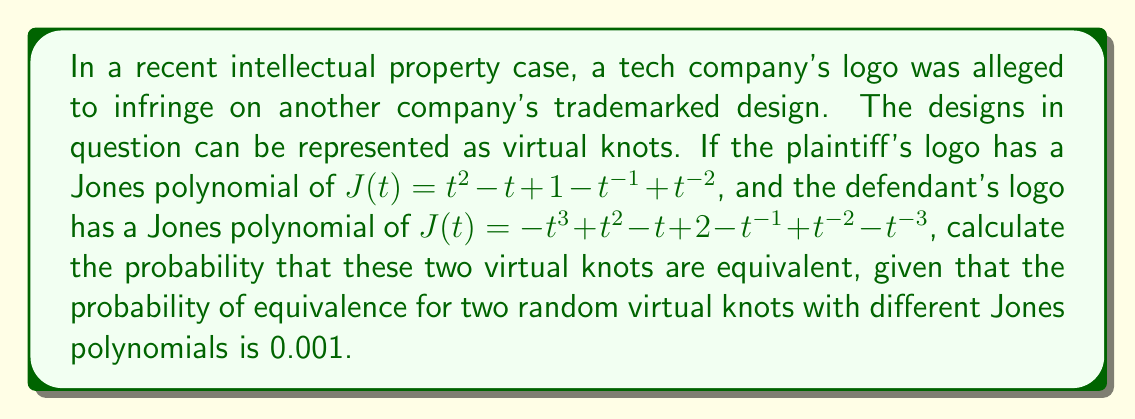Give your solution to this math problem. To solve this problem, we need to follow these steps:

1. Understand the concept of virtual knots and Jones polynomials:
   Virtual knots are generalizations of classical knots, allowing for crossings that can't exist in three-dimensional space. The Jones polynomial is an invariant that can distinguish between different knots.

2. Compare the Jones polynomials:
   Plaintiff's logo: $J(t) = t^2 - t + 1 - t^{-1} + t^{-2}$
   Defendant's logo: $J(t) = -t^3 + t^2 - t + 2 - t^{-1} + t^{-2} - t^{-3}$

   We can see that these polynomials are different, as they have different degrees and coefficients.

3. Apply the given probability:
   Since the Jones polynomials are different, and we're told that the probability of equivalence for two random virtual knots with different Jones polynomials is 0.001, this is our answer.

4. Interpret the result:
   This low probability suggests that it's highly unlikely that the two logos represent equivalent virtual knots, which could be used as evidence in the intellectual property case to argue against infringement.
Answer: 0.001 